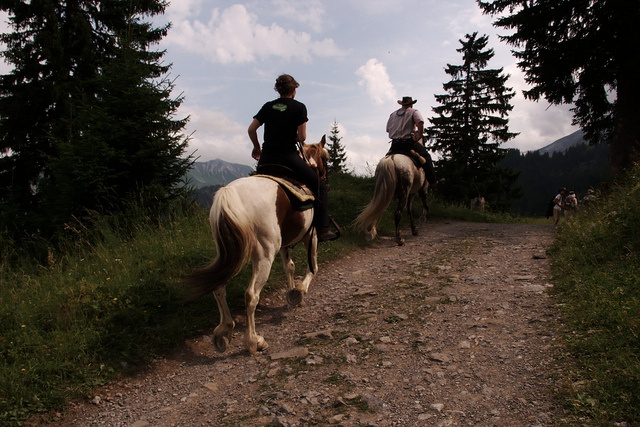Describe the objects in this image and their specific colors. I can see horse in black, maroon, tan, and gray tones, people in black, maroon, gray, and darkgray tones, horse in black, maroon, and gray tones, people in black, gray, and maroon tones, and people in black, maroon, and gray tones in this image. 